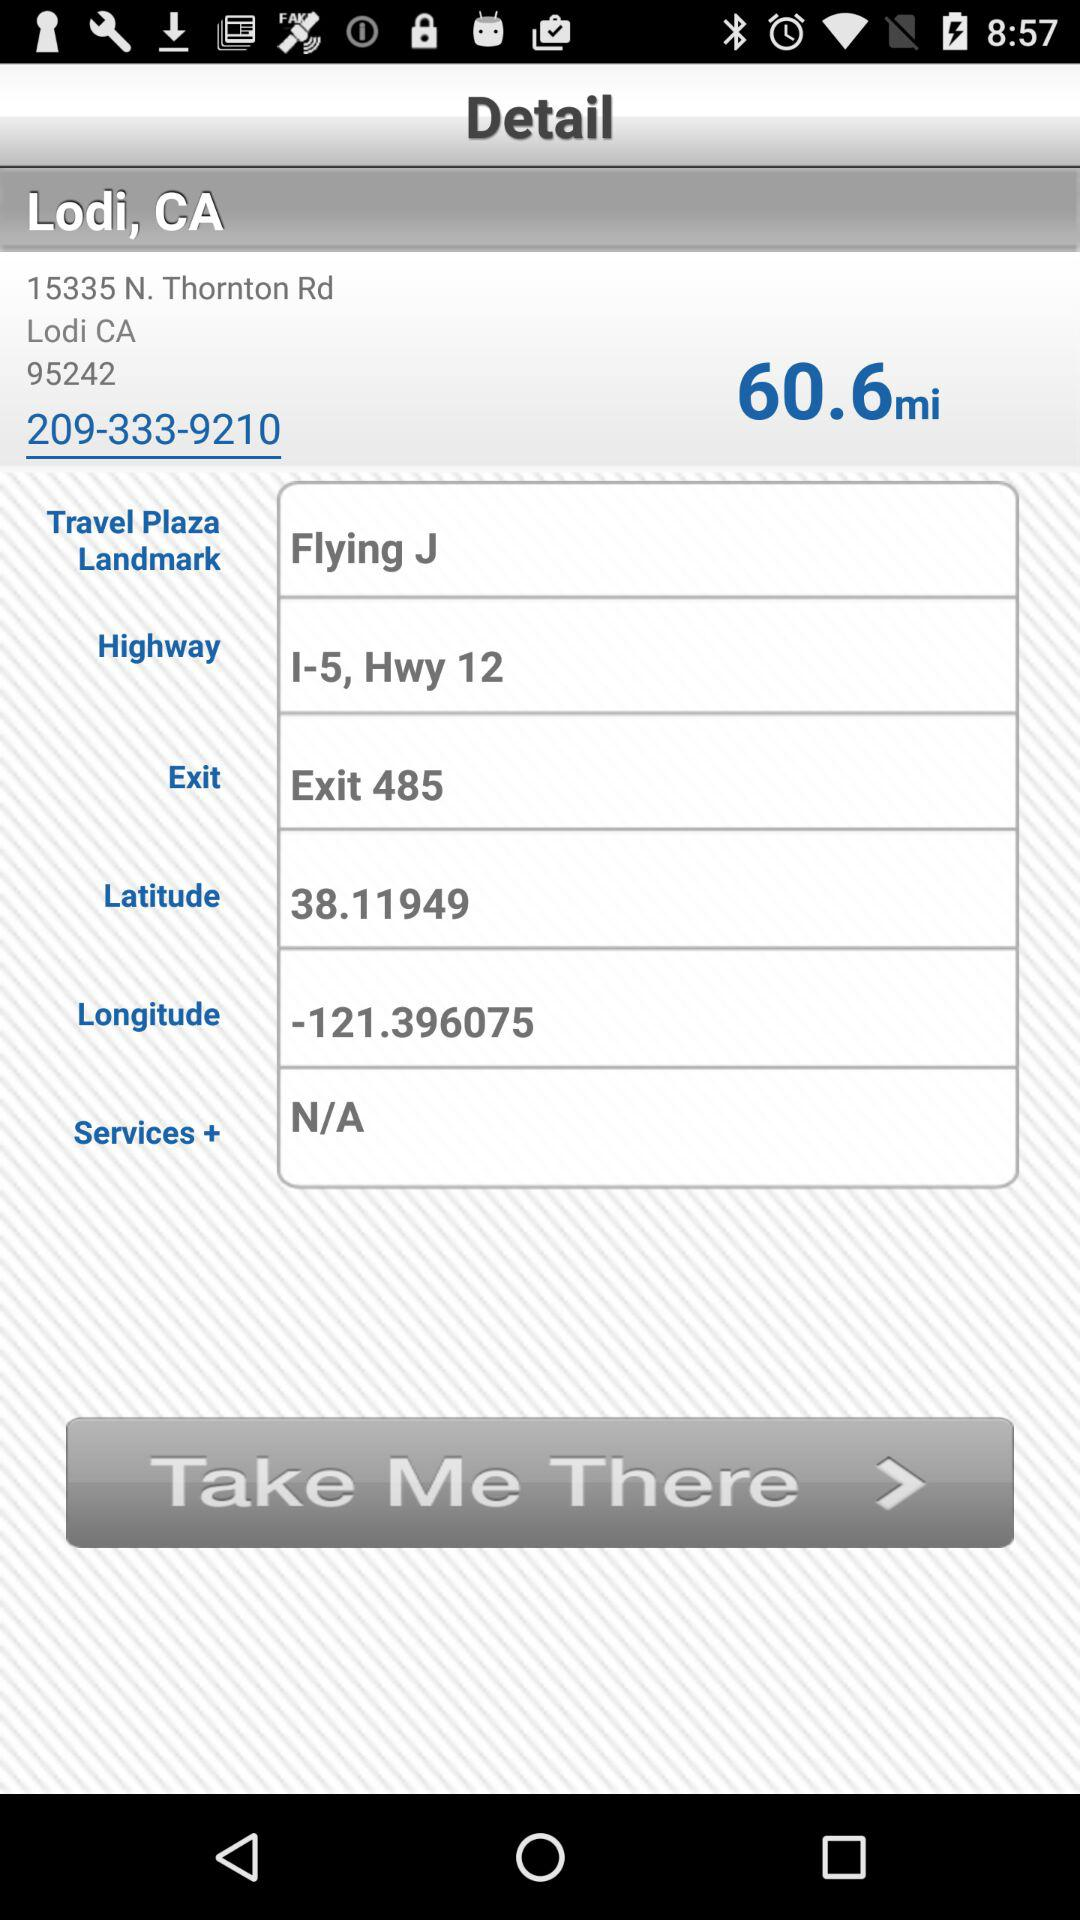What is the location of the user? The location of the user is 15335 N. Thornton Rd., Lodi, CA 95242. 